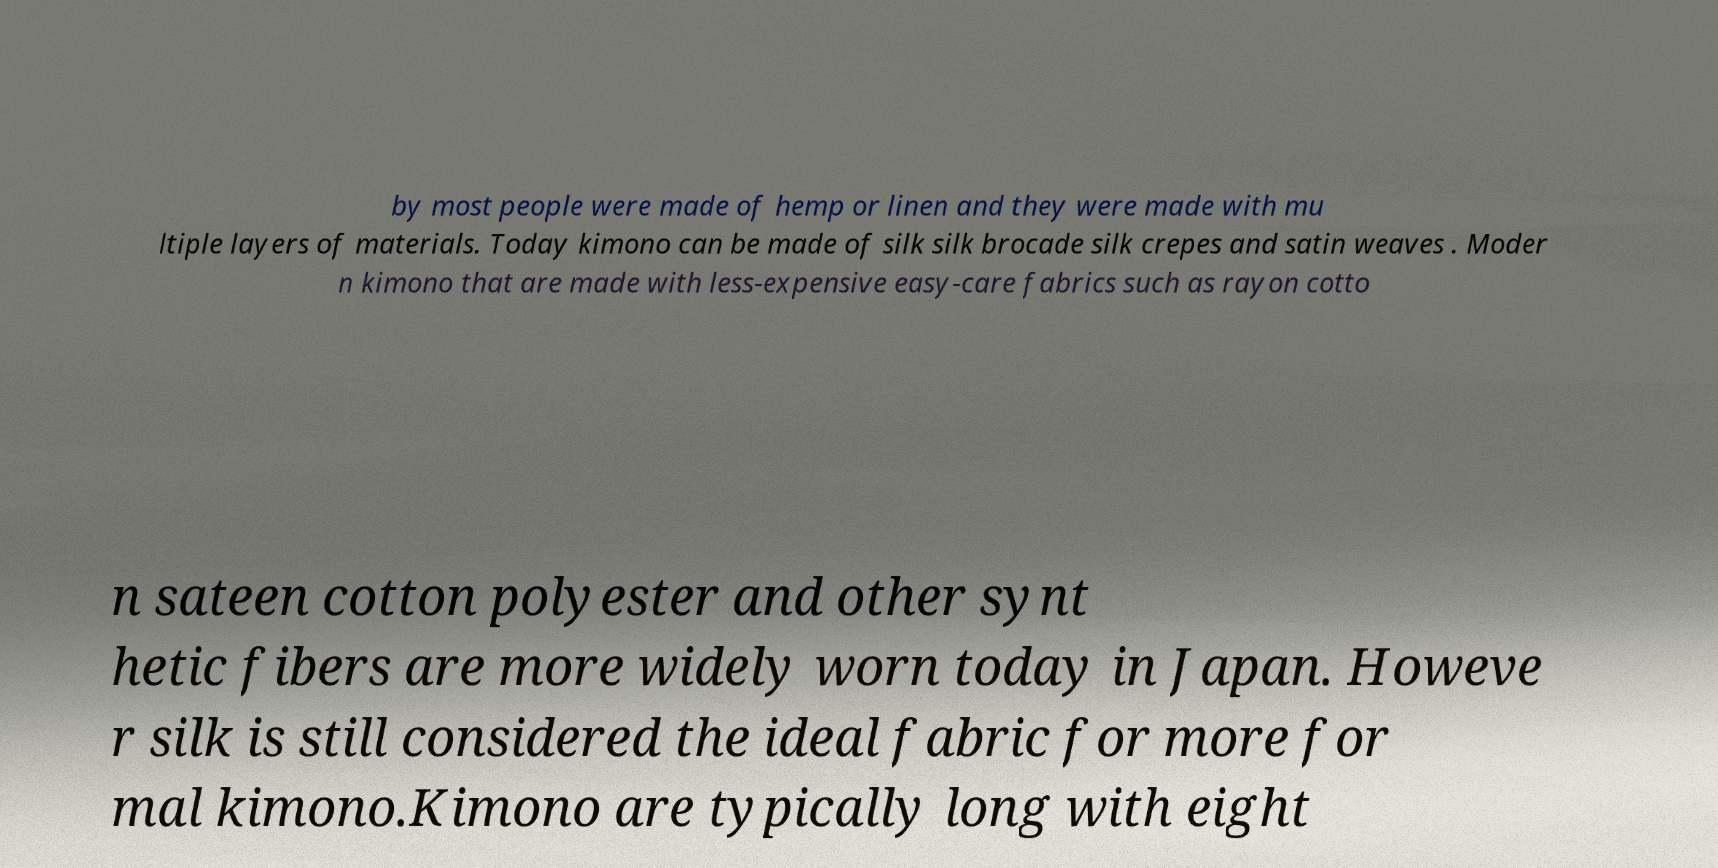There's text embedded in this image that I need extracted. Can you transcribe it verbatim? by most people were made of hemp or linen and they were made with mu ltiple layers of materials. Today kimono can be made of silk silk brocade silk crepes and satin weaves . Moder n kimono that are made with less-expensive easy-care fabrics such as rayon cotto n sateen cotton polyester and other synt hetic fibers are more widely worn today in Japan. Howeve r silk is still considered the ideal fabric for more for mal kimono.Kimono are typically long with eight 